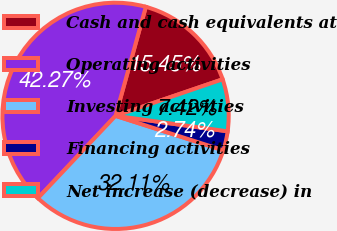<chart> <loc_0><loc_0><loc_500><loc_500><pie_chart><fcel>Cash and cash equivalents at<fcel>Operating activities<fcel>Investing activities<fcel>Financing activities<fcel>Net increase (decrease) in<nl><fcel>15.45%<fcel>42.27%<fcel>32.11%<fcel>2.74%<fcel>7.42%<nl></chart> 